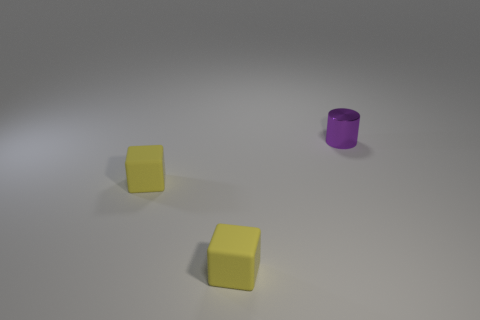What number of other things are the same color as the small shiny cylinder?
Offer a very short reply. 0. What is the tiny cylinder made of?
Ensure brevity in your answer.  Metal. Are there any brown balls?
Offer a terse response. No. Are there the same number of purple metal things that are behind the tiny cylinder and tiny blue matte objects?
Make the answer very short. Yes. Are there any other things that have the same material as the small cylinder?
Provide a short and direct response. No. What number of small objects are yellow rubber objects or yellow shiny cylinders?
Your response must be concise. 2. How many other tiny purple things are the same shape as the tiny purple thing?
Your answer should be compact. 0. How many cyan objects are either cubes or metallic objects?
Your answer should be very brief. 0. Are there more small yellow rubber cubes in front of the small purple cylinder than tiny purple objects?
Ensure brevity in your answer.  Yes. How many yellow matte cubes are the same size as the purple thing?
Make the answer very short. 2. 